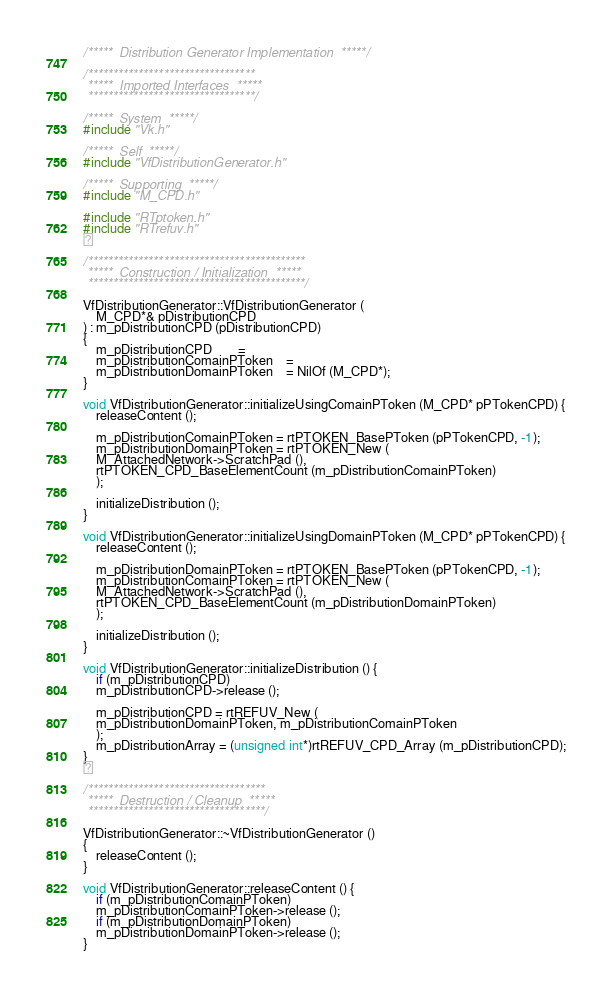Convert code to text. <code><loc_0><loc_0><loc_500><loc_500><_C++_>/*****  Distribution Generator Implementation  *****/

/*********************************
 *****  Imported Interfaces  *****
 *********************************/

/*****  System  *****/
#include "Vk.h"

/*****  Self  *****/
#include "VfDistributionGenerator.h"

/*****  Supporting  *****/
#include "M_CPD.h"

#include "RTptoken.h"
#include "RTrefuv.h"


/*******************************************
 *****  Construction / Initialization  *****
 *******************************************/

VfDistributionGenerator::VfDistributionGenerator (
    M_CPD*& pDistributionCPD
) : m_pDistributionCPD (pDistributionCPD)
{
    m_pDistributionCPD		=
    m_pDistributionComainPToken	=
    m_pDistributionDomainPToken	= NilOf (M_CPD*);
}

void VfDistributionGenerator::initializeUsingComainPToken (M_CPD* pPTokenCPD) {
    releaseContent ();

    m_pDistributionComainPToken = rtPTOKEN_BasePToken (pPTokenCPD, -1);
    m_pDistributionDomainPToken = rtPTOKEN_New (
	M_AttachedNetwork->ScratchPad (),
	rtPTOKEN_CPD_BaseElementCount (m_pDistributionComainPToken)
    );

    initializeDistribution ();
}

void VfDistributionGenerator::initializeUsingDomainPToken (M_CPD* pPTokenCPD) {
    releaseContent ();

    m_pDistributionDomainPToken = rtPTOKEN_BasePToken (pPTokenCPD, -1);
    m_pDistributionComainPToken = rtPTOKEN_New (
	M_AttachedNetwork->ScratchPad (),
	rtPTOKEN_CPD_BaseElementCount (m_pDistributionDomainPToken)
    );

    initializeDistribution ();
}

void VfDistributionGenerator::initializeDistribution () {
    if (m_pDistributionCPD)
	m_pDistributionCPD->release ();

    m_pDistributionCPD = rtREFUV_New (
	m_pDistributionDomainPToken, m_pDistributionComainPToken
    );
    m_pDistributionArray = (unsigned int*)rtREFUV_CPD_Array (m_pDistributionCPD);
}


/***********************************
 *****  Destruction / Cleanup  *****
 ***********************************/

VfDistributionGenerator::~VfDistributionGenerator ()
{
    releaseContent ();
}

void VfDistributionGenerator::releaseContent () {
    if (m_pDistributionComainPToken)
	m_pDistributionComainPToken->release ();
    if (m_pDistributionDomainPToken)
	m_pDistributionDomainPToken->release ();
}
</code> 